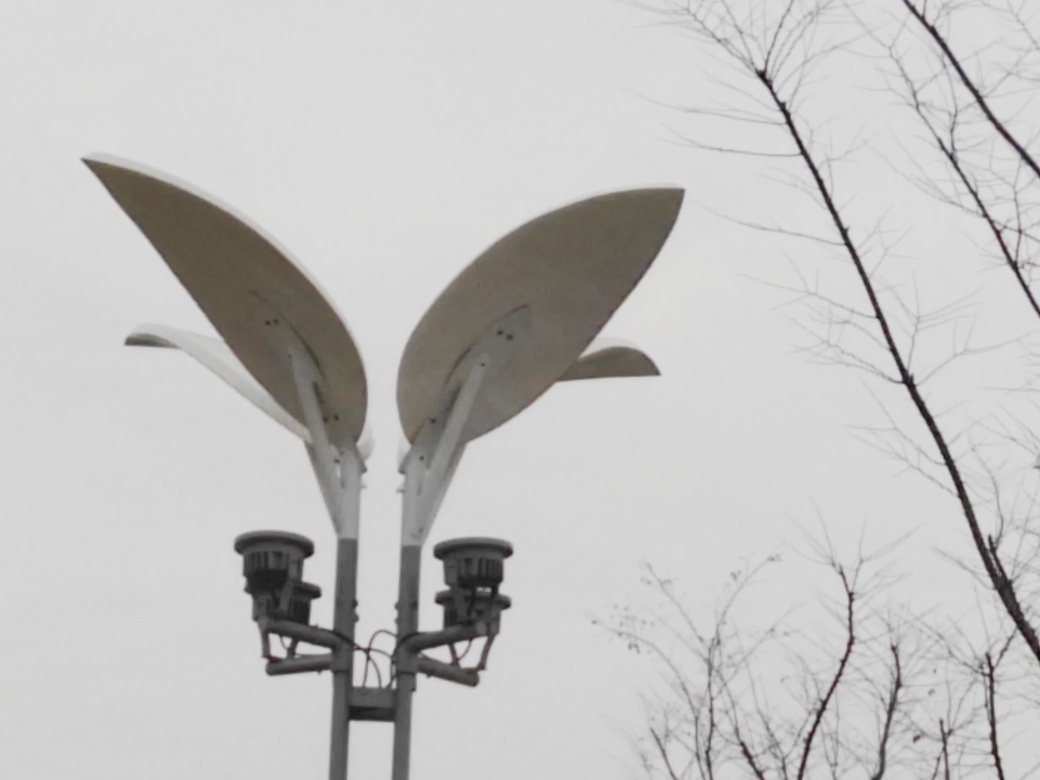Can you describe the structure shown at the center of this photograph? Certainly, the central structure appears to be a modern street lamp designed to resemble a flower. The two large, petal-like elements at the top are probably intended to provide illumination, while their aesthetic design adds a unique, organic touch to an otherwise urban fixture. Does this kind of design serve any purpose beyond lighting? Indeed, while the primary function is illumination, such designs also serve an aesthetic purpose. They can contribute to the visual identity of a space, making it more pleasant and inviting. Additionally, they may reflect local culture or serve as part of a city's beautification and public art initiatives. 